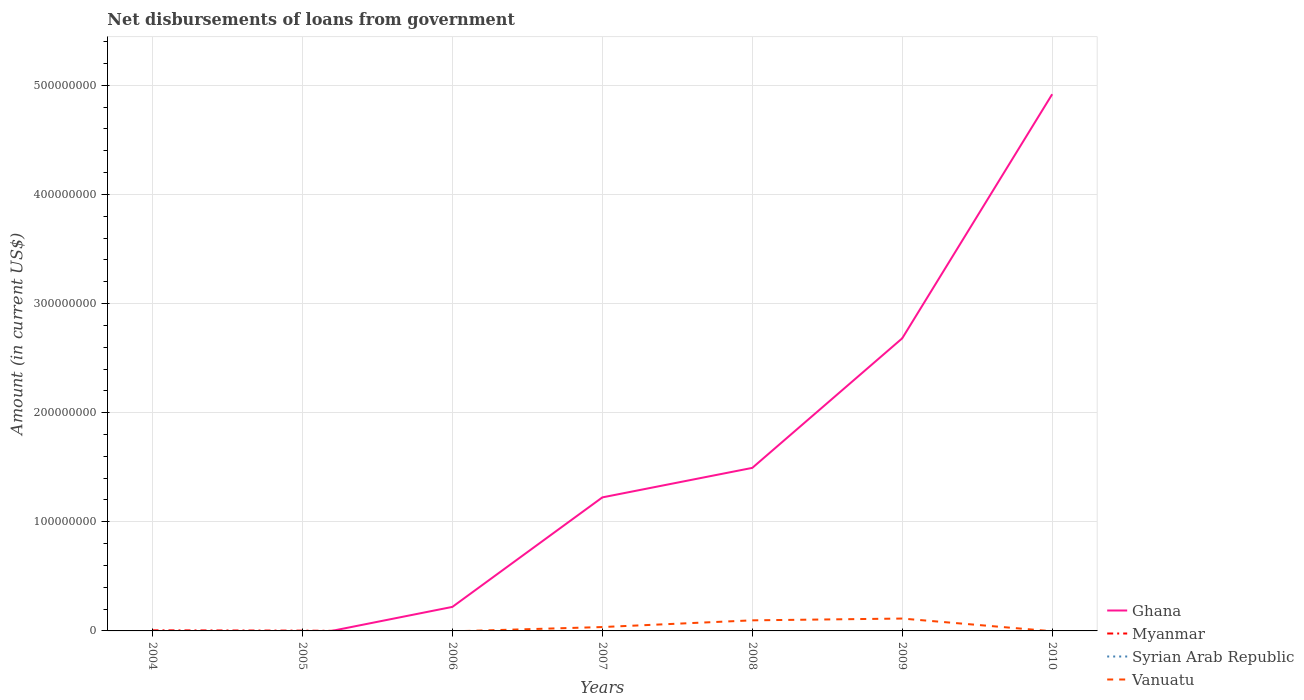Does the line corresponding to Syrian Arab Republic intersect with the line corresponding to Ghana?
Give a very brief answer. No. Across all years, what is the maximum amount of loan disbursed from government in Myanmar?
Make the answer very short. 0. What is the total amount of loan disbursed from government in Ghana in the graph?
Your answer should be compact. -1.27e+08. What is the difference between the highest and the second highest amount of loan disbursed from government in Ghana?
Keep it short and to the point. 4.92e+08. How many years are there in the graph?
Give a very brief answer. 7. Does the graph contain any zero values?
Keep it short and to the point. Yes. How many legend labels are there?
Keep it short and to the point. 4. What is the title of the graph?
Provide a succinct answer. Net disbursements of loans from government. Does "Ukraine" appear as one of the legend labels in the graph?
Keep it short and to the point. No. What is the label or title of the Y-axis?
Offer a very short reply. Amount (in current US$). What is the Amount (in current US$) in Myanmar in 2004?
Provide a short and direct response. 5.40e+05. What is the Amount (in current US$) in Ghana in 2005?
Provide a short and direct response. 0. What is the Amount (in current US$) of Myanmar in 2005?
Keep it short and to the point. 2.64e+05. What is the Amount (in current US$) in Vanuatu in 2005?
Offer a terse response. 0. What is the Amount (in current US$) in Ghana in 2006?
Keep it short and to the point. 2.20e+07. What is the Amount (in current US$) in Myanmar in 2006?
Give a very brief answer. 0. What is the Amount (in current US$) of Vanuatu in 2006?
Provide a short and direct response. 0. What is the Amount (in current US$) in Ghana in 2007?
Offer a terse response. 1.22e+08. What is the Amount (in current US$) of Myanmar in 2007?
Provide a succinct answer. 0. What is the Amount (in current US$) in Vanuatu in 2007?
Give a very brief answer. 3.55e+06. What is the Amount (in current US$) in Ghana in 2008?
Your answer should be very brief. 1.49e+08. What is the Amount (in current US$) in Myanmar in 2008?
Give a very brief answer. 0. What is the Amount (in current US$) of Vanuatu in 2008?
Your response must be concise. 9.70e+06. What is the Amount (in current US$) of Ghana in 2009?
Provide a succinct answer. 2.68e+08. What is the Amount (in current US$) of Vanuatu in 2009?
Your answer should be compact. 1.13e+07. What is the Amount (in current US$) in Ghana in 2010?
Keep it short and to the point. 4.92e+08. What is the Amount (in current US$) of Vanuatu in 2010?
Offer a terse response. 0. Across all years, what is the maximum Amount (in current US$) in Ghana?
Your answer should be compact. 4.92e+08. Across all years, what is the maximum Amount (in current US$) of Myanmar?
Your answer should be very brief. 5.40e+05. Across all years, what is the maximum Amount (in current US$) in Vanuatu?
Keep it short and to the point. 1.13e+07. Across all years, what is the minimum Amount (in current US$) of Ghana?
Your answer should be compact. 0. What is the total Amount (in current US$) in Ghana in the graph?
Offer a very short reply. 1.05e+09. What is the total Amount (in current US$) of Myanmar in the graph?
Your answer should be very brief. 8.04e+05. What is the total Amount (in current US$) of Vanuatu in the graph?
Ensure brevity in your answer.  2.46e+07. What is the difference between the Amount (in current US$) in Myanmar in 2004 and that in 2005?
Offer a terse response. 2.76e+05. What is the difference between the Amount (in current US$) of Ghana in 2006 and that in 2007?
Offer a very short reply. -1.00e+08. What is the difference between the Amount (in current US$) of Ghana in 2006 and that in 2008?
Provide a short and direct response. -1.27e+08. What is the difference between the Amount (in current US$) of Ghana in 2006 and that in 2009?
Give a very brief answer. -2.46e+08. What is the difference between the Amount (in current US$) of Ghana in 2006 and that in 2010?
Give a very brief answer. -4.70e+08. What is the difference between the Amount (in current US$) in Ghana in 2007 and that in 2008?
Keep it short and to the point. -2.70e+07. What is the difference between the Amount (in current US$) of Vanuatu in 2007 and that in 2008?
Offer a terse response. -6.14e+06. What is the difference between the Amount (in current US$) of Ghana in 2007 and that in 2009?
Make the answer very short. -1.46e+08. What is the difference between the Amount (in current US$) of Vanuatu in 2007 and that in 2009?
Your answer should be compact. -7.79e+06. What is the difference between the Amount (in current US$) in Ghana in 2007 and that in 2010?
Keep it short and to the point. -3.69e+08. What is the difference between the Amount (in current US$) of Ghana in 2008 and that in 2009?
Your answer should be very brief. -1.19e+08. What is the difference between the Amount (in current US$) of Vanuatu in 2008 and that in 2009?
Provide a succinct answer. -1.64e+06. What is the difference between the Amount (in current US$) of Ghana in 2008 and that in 2010?
Your response must be concise. -3.42e+08. What is the difference between the Amount (in current US$) in Ghana in 2009 and that in 2010?
Provide a short and direct response. -2.24e+08. What is the difference between the Amount (in current US$) in Myanmar in 2004 and the Amount (in current US$) in Vanuatu in 2007?
Provide a short and direct response. -3.01e+06. What is the difference between the Amount (in current US$) of Myanmar in 2004 and the Amount (in current US$) of Vanuatu in 2008?
Give a very brief answer. -9.16e+06. What is the difference between the Amount (in current US$) of Myanmar in 2004 and the Amount (in current US$) of Vanuatu in 2009?
Your answer should be compact. -1.08e+07. What is the difference between the Amount (in current US$) in Myanmar in 2005 and the Amount (in current US$) in Vanuatu in 2007?
Your answer should be very brief. -3.29e+06. What is the difference between the Amount (in current US$) in Myanmar in 2005 and the Amount (in current US$) in Vanuatu in 2008?
Provide a succinct answer. -9.43e+06. What is the difference between the Amount (in current US$) of Myanmar in 2005 and the Amount (in current US$) of Vanuatu in 2009?
Provide a short and direct response. -1.11e+07. What is the difference between the Amount (in current US$) in Ghana in 2006 and the Amount (in current US$) in Vanuatu in 2007?
Give a very brief answer. 1.85e+07. What is the difference between the Amount (in current US$) in Ghana in 2006 and the Amount (in current US$) in Vanuatu in 2008?
Your answer should be very brief. 1.23e+07. What is the difference between the Amount (in current US$) in Ghana in 2006 and the Amount (in current US$) in Vanuatu in 2009?
Your answer should be compact. 1.07e+07. What is the difference between the Amount (in current US$) in Ghana in 2007 and the Amount (in current US$) in Vanuatu in 2008?
Provide a succinct answer. 1.13e+08. What is the difference between the Amount (in current US$) in Ghana in 2007 and the Amount (in current US$) in Vanuatu in 2009?
Give a very brief answer. 1.11e+08. What is the difference between the Amount (in current US$) of Ghana in 2008 and the Amount (in current US$) of Vanuatu in 2009?
Offer a terse response. 1.38e+08. What is the average Amount (in current US$) of Ghana per year?
Offer a very short reply. 1.51e+08. What is the average Amount (in current US$) in Myanmar per year?
Keep it short and to the point. 1.15e+05. What is the average Amount (in current US$) in Vanuatu per year?
Provide a short and direct response. 3.51e+06. In the year 2007, what is the difference between the Amount (in current US$) of Ghana and Amount (in current US$) of Vanuatu?
Ensure brevity in your answer.  1.19e+08. In the year 2008, what is the difference between the Amount (in current US$) of Ghana and Amount (in current US$) of Vanuatu?
Provide a short and direct response. 1.40e+08. In the year 2009, what is the difference between the Amount (in current US$) of Ghana and Amount (in current US$) of Vanuatu?
Provide a short and direct response. 2.57e+08. What is the ratio of the Amount (in current US$) of Myanmar in 2004 to that in 2005?
Your answer should be compact. 2.05. What is the ratio of the Amount (in current US$) of Ghana in 2006 to that in 2007?
Your answer should be compact. 0.18. What is the ratio of the Amount (in current US$) in Ghana in 2006 to that in 2008?
Your response must be concise. 0.15. What is the ratio of the Amount (in current US$) of Ghana in 2006 to that in 2009?
Offer a terse response. 0.08. What is the ratio of the Amount (in current US$) in Ghana in 2006 to that in 2010?
Ensure brevity in your answer.  0.04. What is the ratio of the Amount (in current US$) in Ghana in 2007 to that in 2008?
Provide a succinct answer. 0.82. What is the ratio of the Amount (in current US$) of Vanuatu in 2007 to that in 2008?
Offer a very short reply. 0.37. What is the ratio of the Amount (in current US$) in Ghana in 2007 to that in 2009?
Provide a short and direct response. 0.46. What is the ratio of the Amount (in current US$) of Vanuatu in 2007 to that in 2009?
Your answer should be compact. 0.31. What is the ratio of the Amount (in current US$) in Ghana in 2007 to that in 2010?
Give a very brief answer. 0.25. What is the ratio of the Amount (in current US$) in Ghana in 2008 to that in 2009?
Keep it short and to the point. 0.56. What is the ratio of the Amount (in current US$) in Vanuatu in 2008 to that in 2009?
Ensure brevity in your answer.  0.86. What is the ratio of the Amount (in current US$) of Ghana in 2008 to that in 2010?
Make the answer very short. 0.3. What is the ratio of the Amount (in current US$) of Ghana in 2009 to that in 2010?
Give a very brief answer. 0.55. What is the difference between the highest and the second highest Amount (in current US$) of Ghana?
Offer a terse response. 2.24e+08. What is the difference between the highest and the second highest Amount (in current US$) of Vanuatu?
Your answer should be compact. 1.64e+06. What is the difference between the highest and the lowest Amount (in current US$) of Ghana?
Offer a very short reply. 4.92e+08. What is the difference between the highest and the lowest Amount (in current US$) of Myanmar?
Ensure brevity in your answer.  5.40e+05. What is the difference between the highest and the lowest Amount (in current US$) in Vanuatu?
Your answer should be compact. 1.13e+07. 